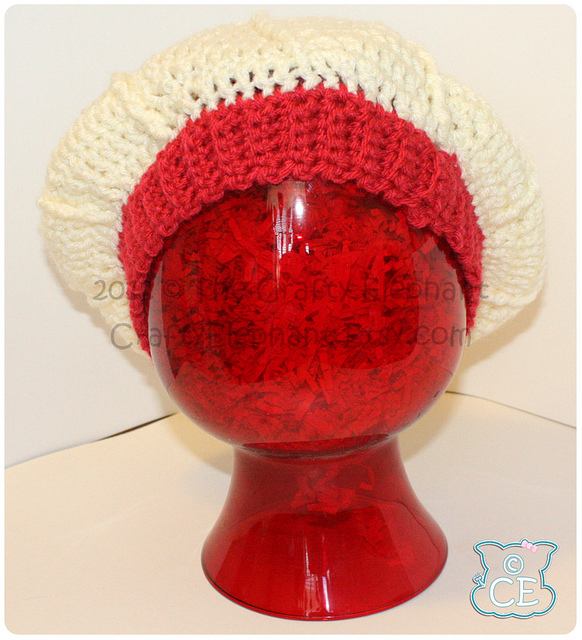Read all the text in this image. 20 CraftyElephant.Etsy.com CE C 